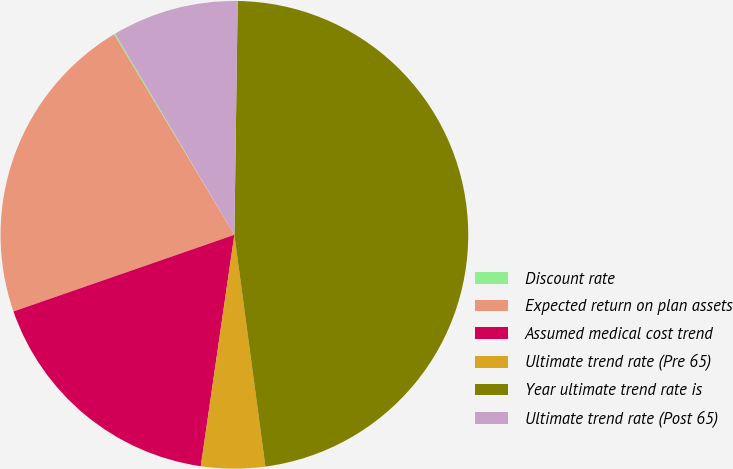Convert chart to OTSL. <chart><loc_0><loc_0><loc_500><loc_500><pie_chart><fcel>Discount rate<fcel>Expected return on plan assets<fcel>Assumed medical cost trend<fcel>Ultimate trend rate (Pre 65)<fcel>Year ultimate trend rate is<fcel>Ultimate trend rate (Post 65)<nl><fcel>0.09%<fcel>21.71%<fcel>17.39%<fcel>4.41%<fcel>47.66%<fcel>8.74%<nl></chart> 